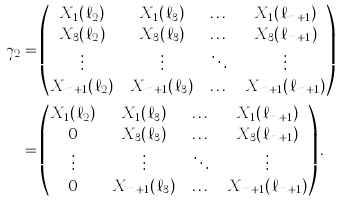Convert formula to latex. <formula><loc_0><loc_0><loc_500><loc_500>\gamma _ { 2 } & = \begin{pmatrix} X _ { 1 } ( \ell _ { 2 } ) & X _ { 1 } ( \ell _ { 3 } ) & \dots & X _ { 1 } ( \ell _ { m + 1 } ) \\ X _ { 3 } ( \ell _ { 2 } ) & X _ { 3 } ( \ell _ { 3 } ) & \dots & X _ { 3 } ( \ell _ { m + 1 } ) \\ \vdots & \vdots & \ddots & \vdots \\ X _ { m + 1 } ( \ell _ { 2 } ) & X _ { m + 1 } ( \ell _ { 3 } ) & \dots & X _ { m + 1 } ( \ell _ { m + 1 } ) \end{pmatrix} \\ & = \begin{pmatrix} X _ { 1 } ( \ell _ { 2 } ) & X _ { 1 } ( \ell _ { 3 } ) & \dots & X _ { 1 } ( \ell _ { m + 1 } ) \\ 0 & X _ { 3 } ( \ell _ { 3 } ) & \dots & X _ { 3 } ( \ell _ { m + 1 } ) \\ \vdots & \vdots & \ddots & \vdots \\ 0 & X _ { m + 1 } ( \ell _ { 3 } ) & \dots & X _ { m + 1 } ( \ell _ { m + 1 } ) \end{pmatrix} .</formula> 